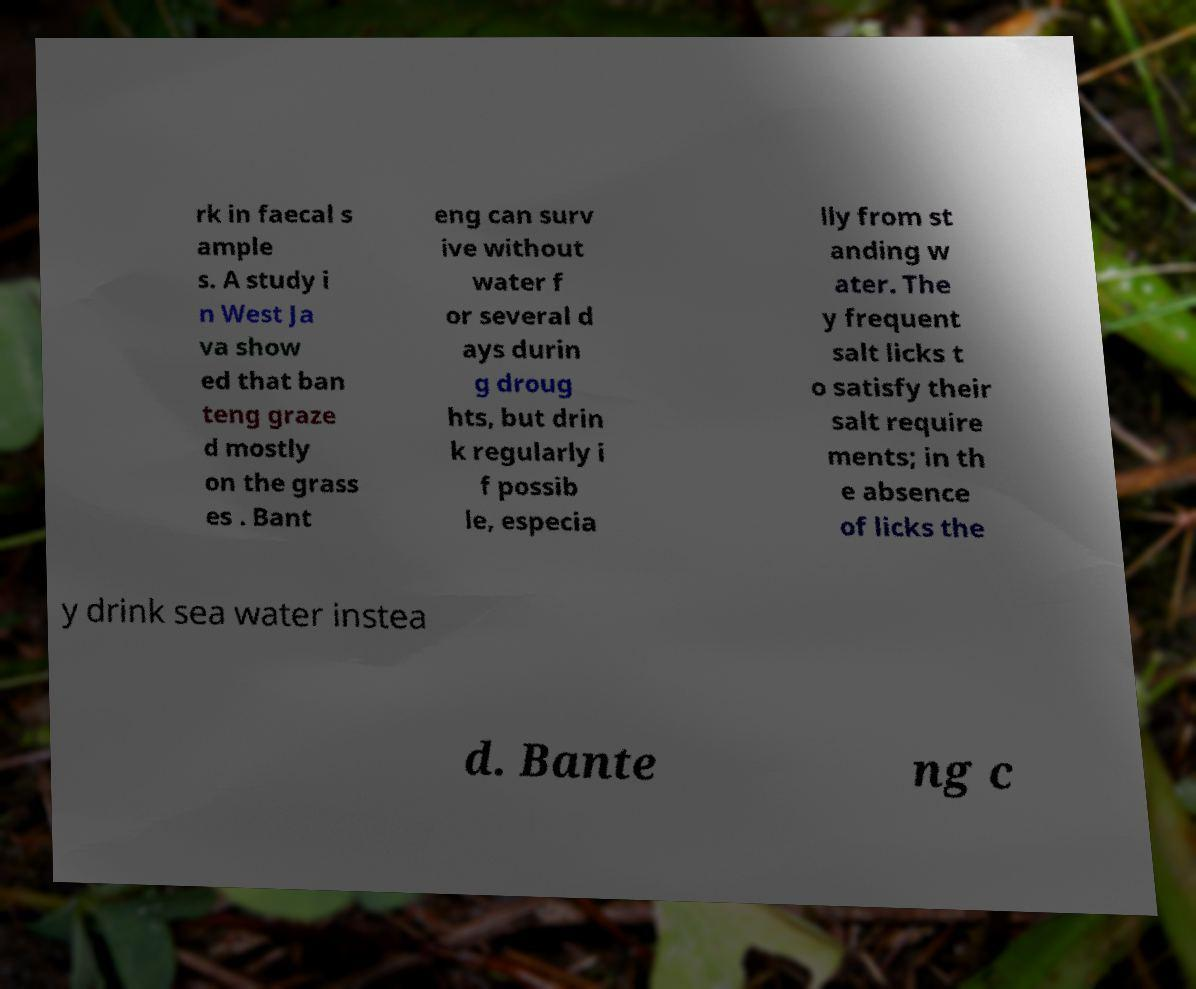I need the written content from this picture converted into text. Can you do that? rk in faecal s ample s. A study i n West Ja va show ed that ban teng graze d mostly on the grass es . Bant eng can surv ive without water f or several d ays durin g droug hts, but drin k regularly i f possib le, especia lly from st anding w ater. The y frequent salt licks t o satisfy their salt require ments; in th e absence of licks the y drink sea water instea d. Bante ng c 